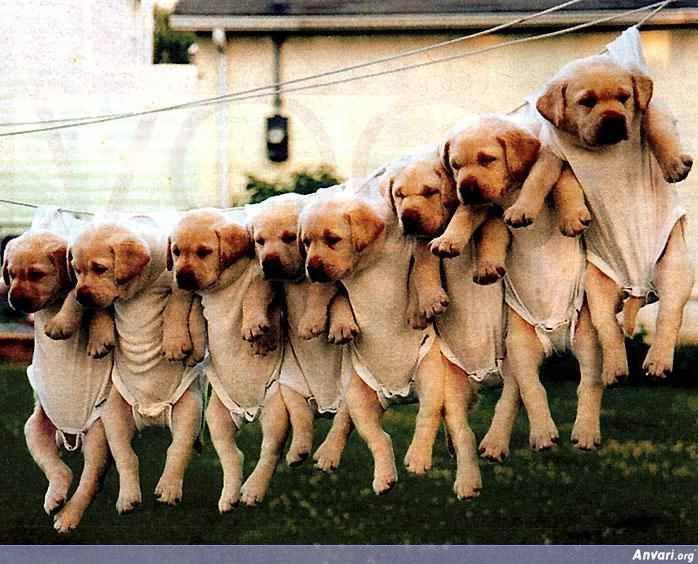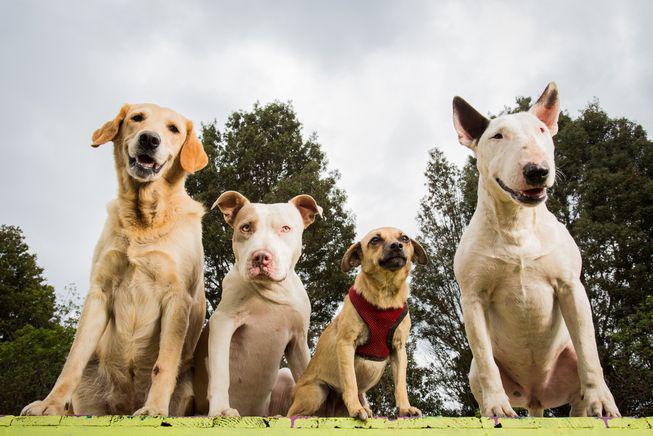The first image is the image on the left, the second image is the image on the right. For the images displayed, is the sentence "Some of the dogs are in the water, and only one dog near the water is not """"blond""""." factually correct? Answer yes or no. No. The first image is the image on the left, the second image is the image on the right. Examine the images to the left and right. Is the description "The dogs in the image on the right are near the water." accurate? Answer yes or no. No. 